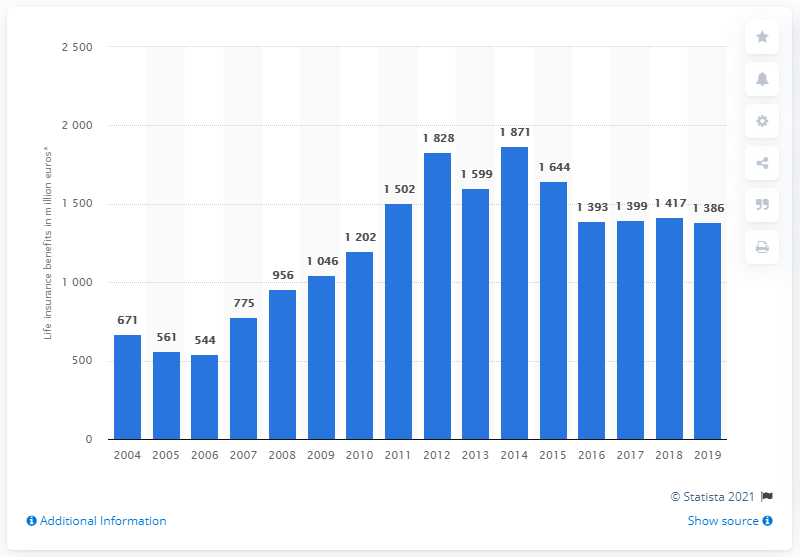Give some essential details in this illustration. In 2019, the value of life benefits paid in the Czech Republic was 1386. 